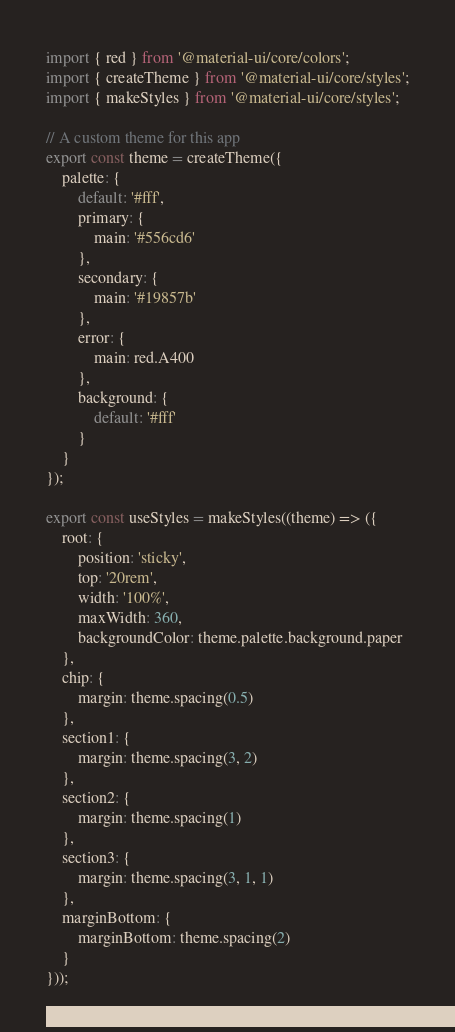Convert code to text. <code><loc_0><loc_0><loc_500><loc_500><_JavaScript_>import { red } from '@material-ui/core/colors';
import { createTheme } from '@material-ui/core/styles';
import { makeStyles } from '@material-ui/core/styles';

// A custom theme for this app
export const theme = createTheme({
    palette: {
        default: '#fff',
        primary: {
            main: '#556cd6'
        },
        secondary: {
            main: '#19857b'
        },
        error: {
            main: red.A400
        },
        background: {
            default: '#fff'
        }
    }
});

export const useStyles = makeStyles((theme) => ({
    root: {
        position: 'sticky',
        top: '20rem',
        width: '100%',
        maxWidth: 360,
        backgroundColor: theme.palette.background.paper
    },
    chip: {
        margin: theme.spacing(0.5)
    },
    section1: {
        margin: theme.spacing(3, 2)
    },
    section2: {
        margin: theme.spacing(1)
    },
    section3: {
        margin: theme.spacing(3, 1, 1)
    },
    marginBottom: {
        marginBottom: theme.spacing(2)
    }
}));

</code> 